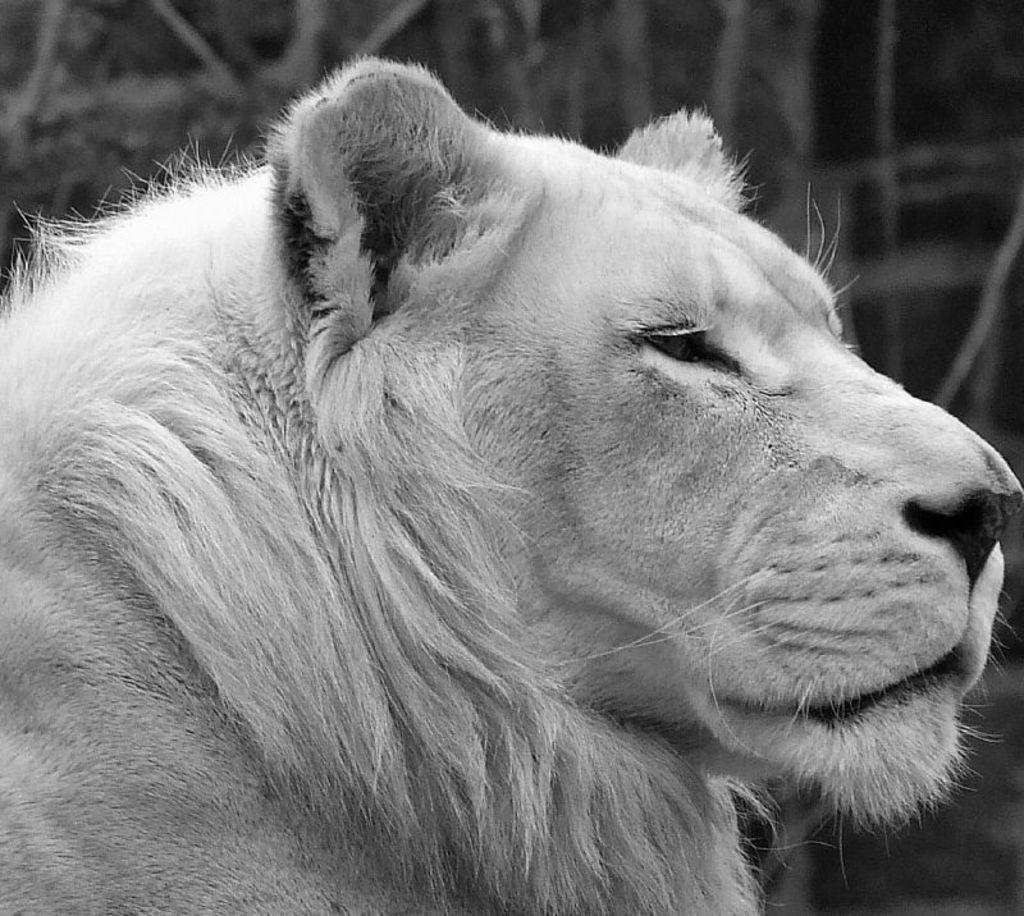What is the main subject in the foreground of the image? There is an animal in the foreground of the image. What can be seen in the background of the image? There are objects in the background of the image. What type of print can be seen on the goat's fur in the image? There is no goat present in the image, and therefore no print on its fur can be observed. 